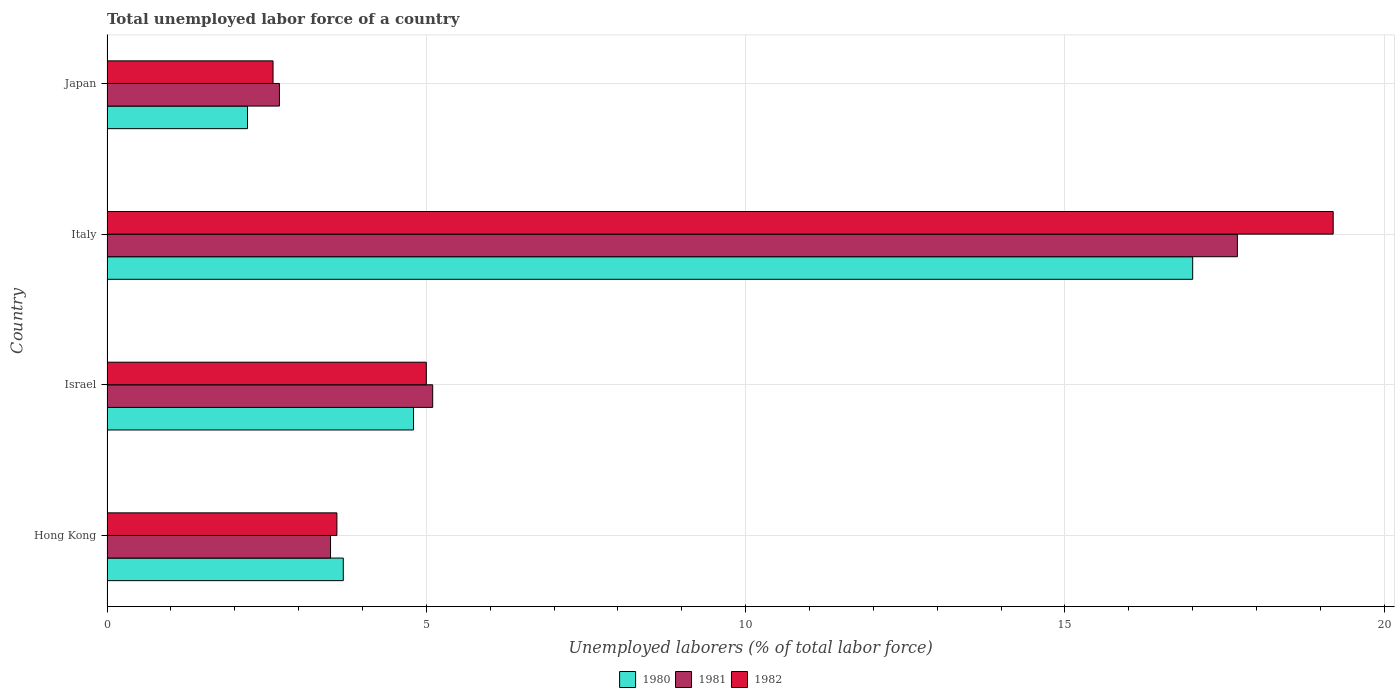How many different coloured bars are there?
Provide a succinct answer. 3. Are the number of bars on each tick of the Y-axis equal?
Make the answer very short. Yes. How many bars are there on the 2nd tick from the bottom?
Your answer should be compact. 3. What is the label of the 4th group of bars from the top?
Provide a short and direct response. Hong Kong. Across all countries, what is the maximum total unemployed labor force in 1982?
Offer a terse response. 19.2. Across all countries, what is the minimum total unemployed labor force in 1982?
Give a very brief answer. 2.6. In which country was the total unemployed labor force in 1982 maximum?
Keep it short and to the point. Italy. What is the total total unemployed labor force in 1982 in the graph?
Your response must be concise. 30.4. What is the difference between the total unemployed labor force in 1981 in Hong Kong and that in Israel?
Ensure brevity in your answer.  -1.6. What is the difference between the total unemployed labor force in 1982 in Israel and the total unemployed labor force in 1980 in Hong Kong?
Offer a very short reply. 1.3. What is the average total unemployed labor force in 1981 per country?
Your answer should be compact. 7.25. What is the difference between the total unemployed labor force in 1982 and total unemployed labor force in 1981 in Japan?
Make the answer very short. -0.1. In how many countries, is the total unemployed labor force in 1980 greater than 11 %?
Provide a succinct answer. 1. What is the ratio of the total unemployed labor force in 1980 in Italy to that in Japan?
Your response must be concise. 7.73. Is the difference between the total unemployed labor force in 1982 in Israel and Italy greater than the difference between the total unemployed labor force in 1981 in Israel and Italy?
Your answer should be very brief. No. What is the difference between the highest and the second highest total unemployed labor force in 1981?
Offer a terse response. 12.6. What is the difference between the highest and the lowest total unemployed labor force in 1980?
Make the answer very short. 14.8. In how many countries, is the total unemployed labor force in 1981 greater than the average total unemployed labor force in 1981 taken over all countries?
Your response must be concise. 1. What does the 1st bar from the top in Hong Kong represents?
Provide a short and direct response. 1982. What does the 3rd bar from the bottom in Italy represents?
Make the answer very short. 1982. How many bars are there?
Keep it short and to the point. 12. How many countries are there in the graph?
Your response must be concise. 4. What is the difference between two consecutive major ticks on the X-axis?
Your answer should be compact. 5. Does the graph contain grids?
Keep it short and to the point. Yes. Where does the legend appear in the graph?
Provide a short and direct response. Bottom center. How many legend labels are there?
Ensure brevity in your answer.  3. How are the legend labels stacked?
Your response must be concise. Horizontal. What is the title of the graph?
Give a very brief answer. Total unemployed labor force of a country. Does "2009" appear as one of the legend labels in the graph?
Make the answer very short. No. What is the label or title of the X-axis?
Your response must be concise. Unemployed laborers (% of total labor force). What is the Unemployed laborers (% of total labor force) in 1980 in Hong Kong?
Keep it short and to the point. 3.7. What is the Unemployed laborers (% of total labor force) of 1982 in Hong Kong?
Provide a short and direct response. 3.6. What is the Unemployed laborers (% of total labor force) in 1980 in Israel?
Make the answer very short. 4.8. What is the Unemployed laborers (% of total labor force) in 1981 in Israel?
Your response must be concise. 5.1. What is the Unemployed laborers (% of total labor force) in 1982 in Israel?
Offer a very short reply. 5. What is the Unemployed laborers (% of total labor force) of 1981 in Italy?
Offer a terse response. 17.7. What is the Unemployed laborers (% of total labor force) in 1982 in Italy?
Your answer should be very brief. 19.2. What is the Unemployed laborers (% of total labor force) of 1980 in Japan?
Your answer should be very brief. 2.2. What is the Unemployed laborers (% of total labor force) in 1981 in Japan?
Offer a terse response. 2.7. What is the Unemployed laborers (% of total labor force) in 1982 in Japan?
Provide a succinct answer. 2.6. Across all countries, what is the maximum Unemployed laborers (% of total labor force) of 1981?
Offer a very short reply. 17.7. Across all countries, what is the maximum Unemployed laborers (% of total labor force) of 1982?
Make the answer very short. 19.2. Across all countries, what is the minimum Unemployed laborers (% of total labor force) in 1980?
Keep it short and to the point. 2.2. Across all countries, what is the minimum Unemployed laborers (% of total labor force) in 1981?
Provide a short and direct response. 2.7. Across all countries, what is the minimum Unemployed laborers (% of total labor force) of 1982?
Offer a very short reply. 2.6. What is the total Unemployed laborers (% of total labor force) of 1980 in the graph?
Your answer should be very brief. 27.7. What is the total Unemployed laborers (% of total labor force) in 1981 in the graph?
Give a very brief answer. 29. What is the total Unemployed laborers (% of total labor force) of 1982 in the graph?
Your answer should be compact. 30.4. What is the difference between the Unemployed laborers (% of total labor force) of 1981 in Hong Kong and that in Israel?
Provide a succinct answer. -1.6. What is the difference between the Unemployed laborers (% of total labor force) of 1980 in Hong Kong and that in Italy?
Offer a terse response. -13.3. What is the difference between the Unemployed laborers (% of total labor force) of 1981 in Hong Kong and that in Italy?
Provide a short and direct response. -14.2. What is the difference between the Unemployed laborers (% of total labor force) in 1982 in Hong Kong and that in Italy?
Provide a short and direct response. -15.6. What is the difference between the Unemployed laborers (% of total labor force) of 1982 in Hong Kong and that in Japan?
Make the answer very short. 1. What is the difference between the Unemployed laborers (% of total labor force) of 1980 in Israel and that in Japan?
Give a very brief answer. 2.6. What is the difference between the Unemployed laborers (% of total labor force) of 1982 in Italy and that in Japan?
Offer a very short reply. 16.6. What is the difference between the Unemployed laborers (% of total labor force) in 1980 in Hong Kong and the Unemployed laborers (% of total labor force) in 1981 in Israel?
Provide a succinct answer. -1.4. What is the difference between the Unemployed laborers (% of total labor force) in 1981 in Hong Kong and the Unemployed laborers (% of total labor force) in 1982 in Israel?
Offer a terse response. -1.5. What is the difference between the Unemployed laborers (% of total labor force) in 1980 in Hong Kong and the Unemployed laborers (% of total labor force) in 1981 in Italy?
Offer a very short reply. -14. What is the difference between the Unemployed laborers (% of total labor force) in 1980 in Hong Kong and the Unemployed laborers (% of total labor force) in 1982 in Italy?
Keep it short and to the point. -15.5. What is the difference between the Unemployed laborers (% of total labor force) in 1981 in Hong Kong and the Unemployed laborers (% of total labor force) in 1982 in Italy?
Your answer should be very brief. -15.7. What is the difference between the Unemployed laborers (% of total labor force) in 1980 in Israel and the Unemployed laborers (% of total labor force) in 1982 in Italy?
Your response must be concise. -14.4. What is the difference between the Unemployed laborers (% of total labor force) of 1981 in Israel and the Unemployed laborers (% of total labor force) of 1982 in Italy?
Ensure brevity in your answer.  -14.1. What is the difference between the Unemployed laborers (% of total labor force) in 1980 in Israel and the Unemployed laborers (% of total labor force) in 1982 in Japan?
Provide a succinct answer. 2.2. What is the difference between the Unemployed laborers (% of total labor force) of 1980 in Italy and the Unemployed laborers (% of total labor force) of 1982 in Japan?
Offer a terse response. 14.4. What is the average Unemployed laborers (% of total labor force) of 1980 per country?
Your answer should be compact. 6.92. What is the average Unemployed laborers (% of total labor force) in 1981 per country?
Your answer should be compact. 7.25. What is the average Unemployed laborers (% of total labor force) of 1982 per country?
Keep it short and to the point. 7.6. What is the difference between the Unemployed laborers (% of total labor force) of 1980 and Unemployed laborers (% of total labor force) of 1981 in Hong Kong?
Provide a short and direct response. 0.2. What is the difference between the Unemployed laborers (% of total labor force) in 1981 and Unemployed laborers (% of total labor force) in 1982 in Hong Kong?
Your answer should be compact. -0.1. What is the difference between the Unemployed laborers (% of total labor force) of 1980 and Unemployed laborers (% of total labor force) of 1981 in Israel?
Ensure brevity in your answer.  -0.3. What is the difference between the Unemployed laborers (% of total labor force) of 1980 and Unemployed laborers (% of total labor force) of 1982 in Israel?
Your response must be concise. -0.2. What is the difference between the Unemployed laborers (% of total labor force) in 1981 and Unemployed laborers (% of total labor force) in 1982 in Italy?
Make the answer very short. -1.5. What is the difference between the Unemployed laborers (% of total labor force) of 1981 and Unemployed laborers (% of total labor force) of 1982 in Japan?
Provide a short and direct response. 0.1. What is the ratio of the Unemployed laborers (% of total labor force) of 1980 in Hong Kong to that in Israel?
Provide a succinct answer. 0.77. What is the ratio of the Unemployed laborers (% of total labor force) in 1981 in Hong Kong to that in Israel?
Ensure brevity in your answer.  0.69. What is the ratio of the Unemployed laborers (% of total labor force) of 1982 in Hong Kong to that in Israel?
Provide a succinct answer. 0.72. What is the ratio of the Unemployed laborers (% of total labor force) in 1980 in Hong Kong to that in Italy?
Your answer should be very brief. 0.22. What is the ratio of the Unemployed laborers (% of total labor force) in 1981 in Hong Kong to that in Italy?
Offer a terse response. 0.2. What is the ratio of the Unemployed laborers (% of total labor force) of 1982 in Hong Kong to that in Italy?
Provide a short and direct response. 0.19. What is the ratio of the Unemployed laborers (% of total labor force) of 1980 in Hong Kong to that in Japan?
Keep it short and to the point. 1.68. What is the ratio of the Unemployed laborers (% of total labor force) of 1981 in Hong Kong to that in Japan?
Offer a very short reply. 1.3. What is the ratio of the Unemployed laborers (% of total labor force) in 1982 in Hong Kong to that in Japan?
Your answer should be very brief. 1.38. What is the ratio of the Unemployed laborers (% of total labor force) of 1980 in Israel to that in Italy?
Make the answer very short. 0.28. What is the ratio of the Unemployed laborers (% of total labor force) in 1981 in Israel to that in Italy?
Your response must be concise. 0.29. What is the ratio of the Unemployed laborers (% of total labor force) in 1982 in Israel to that in Italy?
Keep it short and to the point. 0.26. What is the ratio of the Unemployed laborers (% of total labor force) in 1980 in Israel to that in Japan?
Provide a succinct answer. 2.18. What is the ratio of the Unemployed laborers (% of total labor force) in 1981 in Israel to that in Japan?
Your answer should be compact. 1.89. What is the ratio of the Unemployed laborers (% of total labor force) of 1982 in Israel to that in Japan?
Offer a very short reply. 1.92. What is the ratio of the Unemployed laborers (% of total labor force) in 1980 in Italy to that in Japan?
Provide a short and direct response. 7.73. What is the ratio of the Unemployed laborers (% of total labor force) of 1981 in Italy to that in Japan?
Give a very brief answer. 6.56. What is the ratio of the Unemployed laborers (% of total labor force) of 1982 in Italy to that in Japan?
Make the answer very short. 7.38. What is the difference between the highest and the second highest Unemployed laborers (% of total labor force) in 1980?
Make the answer very short. 12.2. What is the difference between the highest and the lowest Unemployed laborers (% of total labor force) of 1981?
Ensure brevity in your answer.  15. What is the difference between the highest and the lowest Unemployed laborers (% of total labor force) of 1982?
Your answer should be very brief. 16.6. 